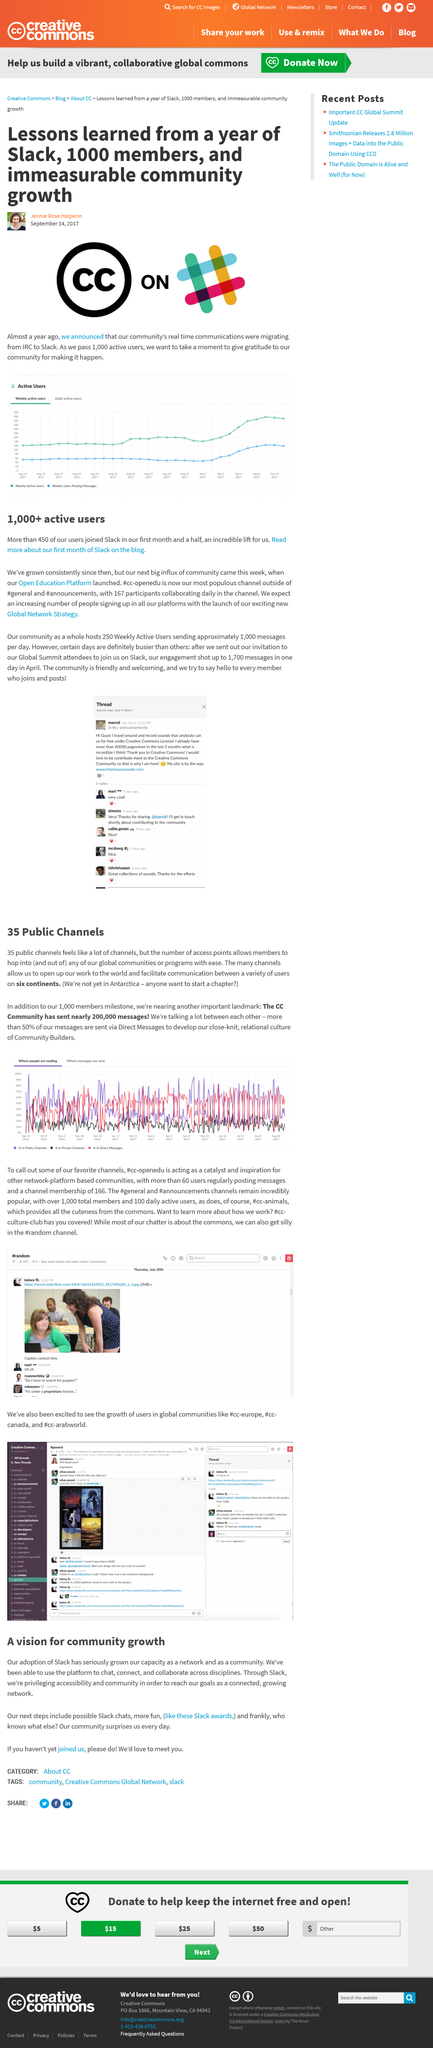Give some essential details in this illustration. Slack has replaced IRC as the preferred platform for real-time community communication. After a year on Slack, the number of active users increased to 1000. The migration from IRC to Slack occurred in 2017, as stated in the text "How recent Was the change from irc to slack? ? The irc to slack migration happened in 2017 ..". 